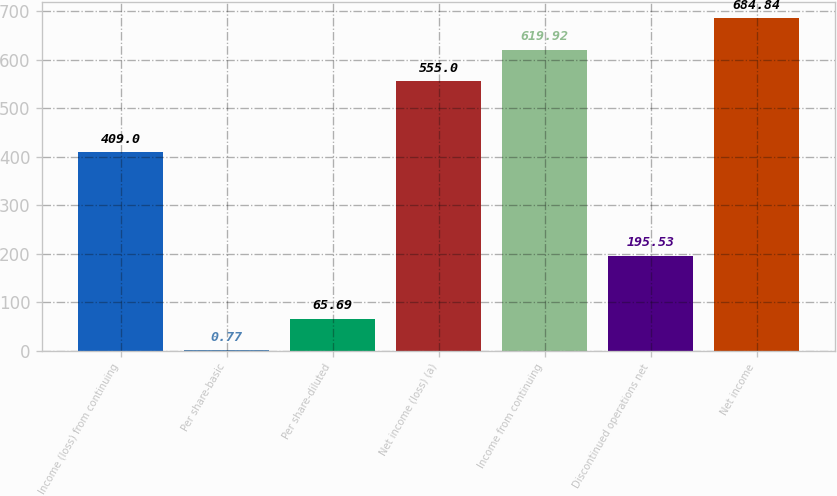Convert chart to OTSL. <chart><loc_0><loc_0><loc_500><loc_500><bar_chart><fcel>Income (loss) from continuing<fcel>Per share-basic<fcel>Per share-diluted<fcel>Net income (loss) (a)<fcel>Income from continuing<fcel>Discontinued operations net<fcel>Net income<nl><fcel>409<fcel>0.77<fcel>65.69<fcel>555<fcel>619.92<fcel>195.53<fcel>684.84<nl></chart> 